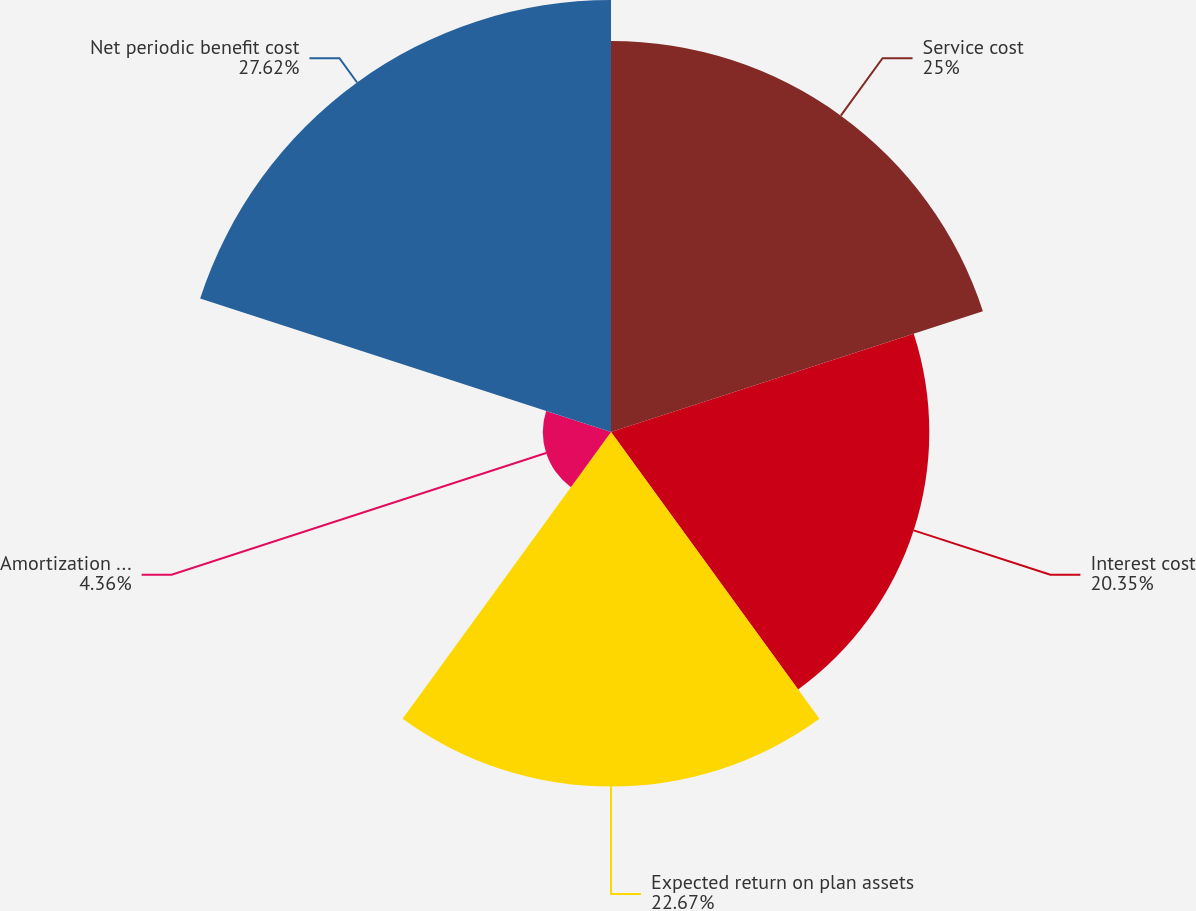<chart> <loc_0><loc_0><loc_500><loc_500><pie_chart><fcel>Service cost<fcel>Interest cost<fcel>Expected return on plan assets<fcel>Amortization of actuarial gain<fcel>Net periodic benefit cost<nl><fcel>25.0%<fcel>20.35%<fcel>22.67%<fcel>4.36%<fcel>27.62%<nl></chart> 